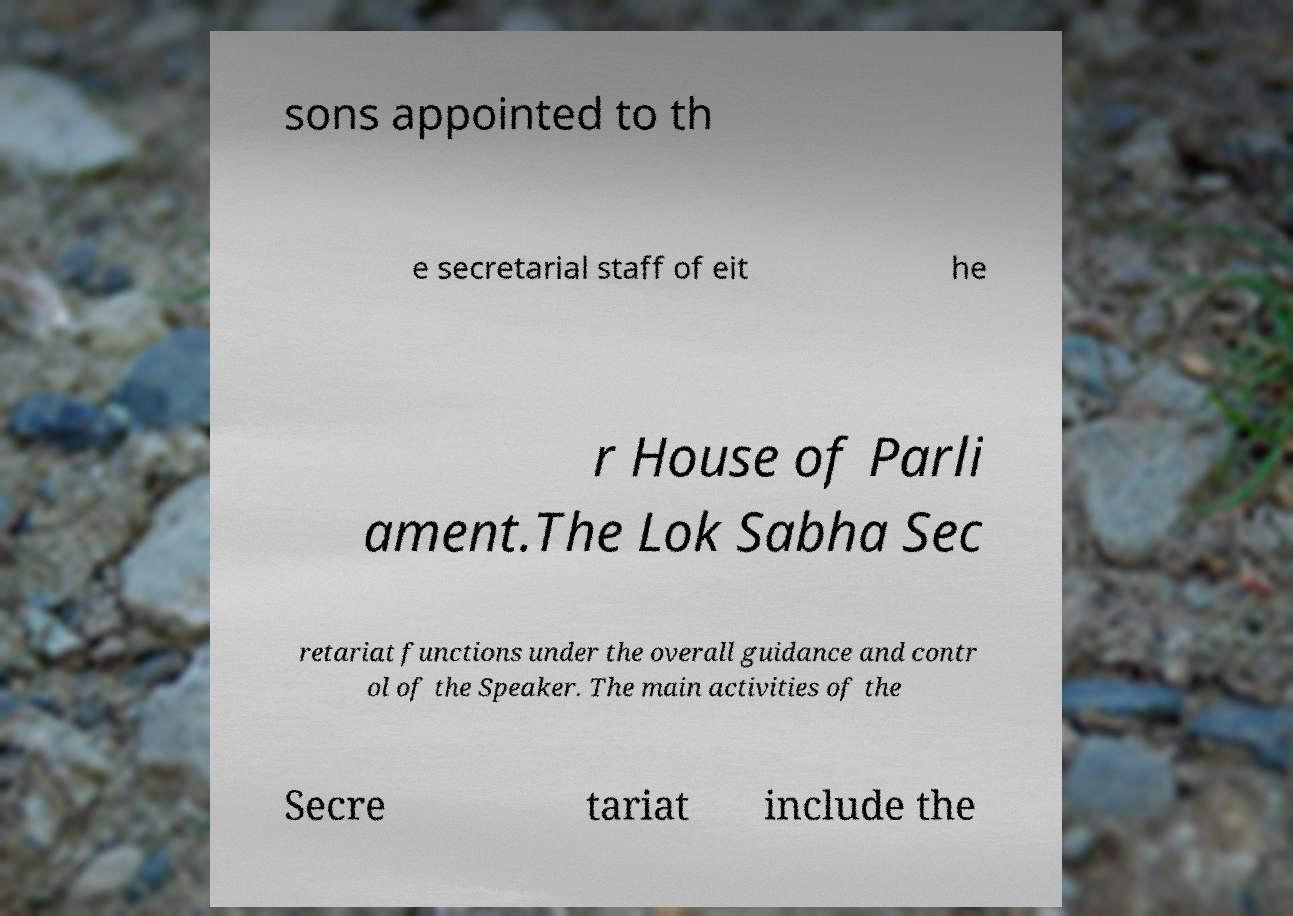For documentation purposes, I need the text within this image transcribed. Could you provide that? sons appointed to th e secretarial staff of eit he r House of Parli ament.The Lok Sabha Sec retariat functions under the overall guidance and contr ol of the Speaker. The main activities of the Secre tariat include the 